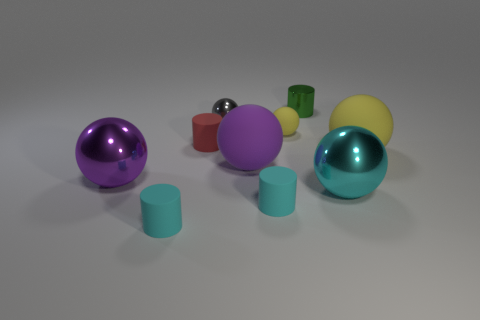Imagine if these objects had weights; how would you describe their placement in relation to stability? If we were to assume these objects have varying weights, their placement appears stable with no imminent risk of tipping or rolling. The spheres might suggest the possibility of movement; however, there are no inclines or external forces depicted that would disrupt their stillness. The cylinders add a sense of balanced support to the composition. 